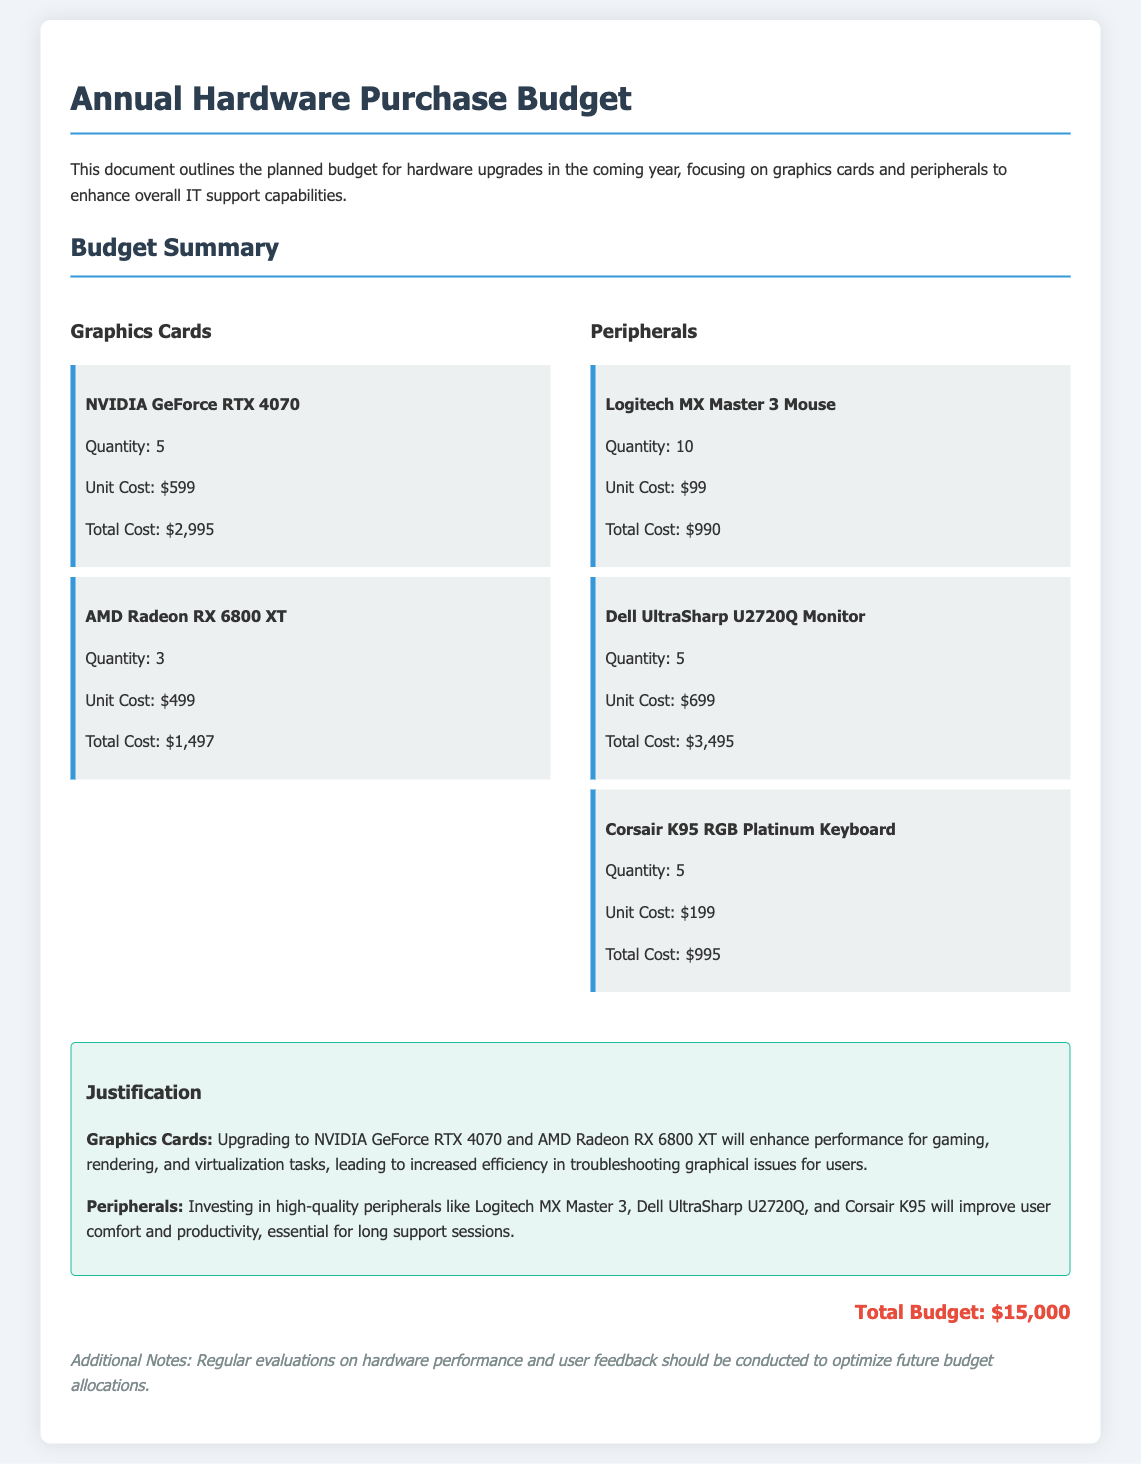what is the total cost for the NVIDIA GeForce RTX 4070? The total cost for the NVIDIA GeForce RTX 4070 is detailed in the document as $2,995.
Answer: $2,995 how many AMD Radeon RX 6800 XT graphics cards are planned for purchase? The document specifies that 3 units of AMD Radeon RX 6800 XT are planned for purchase.
Answer: 3 what is the unit cost for the Dell UltraSharp U2720Q Monitor? The document states that the unit cost for the Dell UltraSharp U2720Q Monitor is $699.
Answer: $699 what is the total budget allocated for all hardware purchases? The total budget is explicitly stated as $15,000 in the document.
Answer: $15,000 what improvement does upgrading peripherals aim to provide? The justification mentions that upgrading peripherals aims to improve user comfort and productivity.
Answer: user comfort and productivity how many Logitech MX Master 3 Mice are included in the budget? The document indicates that there are 10 Logitech MX Master 3 Mice included in the budget.
Answer: 10 what specific advantage does the NVIDIA GeForce RTX 4070 offer? According to the justification, it offers enhanced performance for gaming, rendering, and virtualization tasks.
Answer: enhanced performance for gaming, rendering, and virtualization tasks which keyboard model is listed for purchase? The document lists the Corsair K95 RGB Platinum Keyboard as part of the purchase.
Answer: Corsair K95 RGB Platinum Keyboard what is the total cost for all peripherals listed? The total cost for all peripherals is calculated as $4,480 based on their individual costs in the document.
Answer: $4,480 